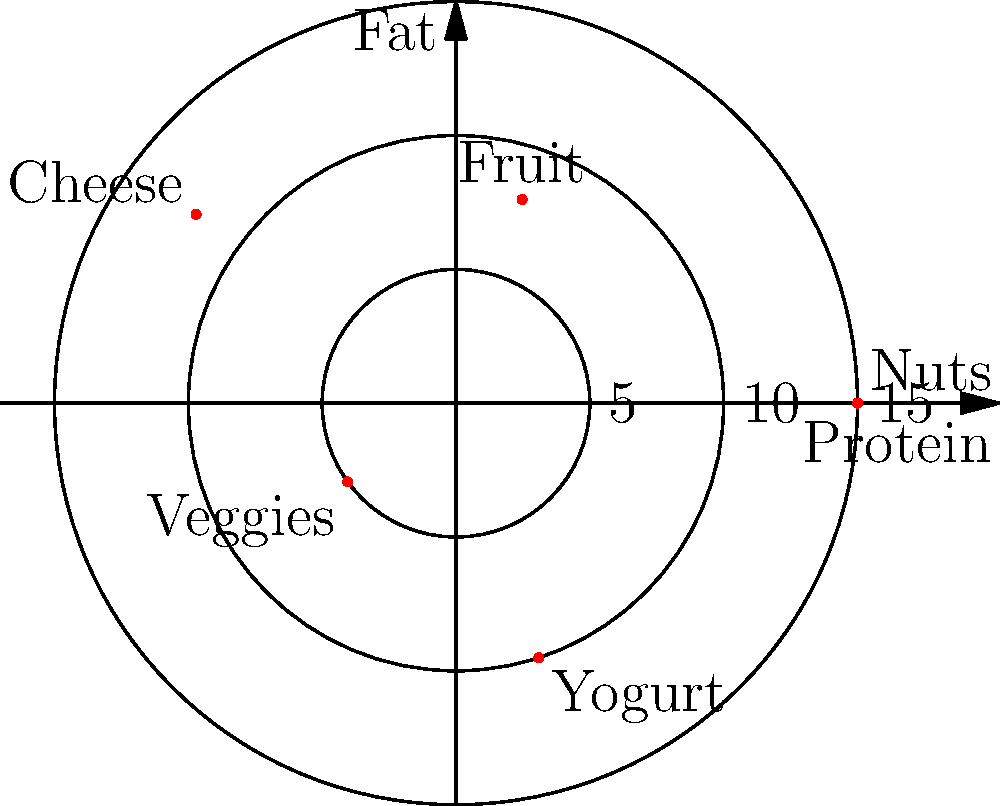The polar graph above represents the nutritional content of five popular child snacks. Each snack is plotted based on its protein content (x-axis) and fat content (y-axis) in grams per serving. Which snack has the highest protein content? To determine which snack has the highest protein content, we need to analyze the x-axis values for each plotted point:

1. First, identify each snack on the graph:
   - Nuts: located at 0 degrees
   - Fruit: located at 72 degrees
   - Cheese: located at 144 degrees
   - Veggies: located at 216 degrees
   - Yogurt: located at 288 degrees

2. The protein content is represented by the x-axis (horizontal axis).

3. Compare the x-axis values for each snack:
   - Nuts: Furthest right on the x-axis, about 15 grams
   - Fruit: Close to the origin, about 8 grams
   - Cheese: Negative x-value, about -12 grams
   - Veggies: Negative x-value, close to origin, about -5 grams
   - Yogurt: Positive x-value, about 10 grams

4. The snack with the highest positive x-value has the highest protein content.

5. Nuts have the highest x-value at approximately 15 grams of protein per serving.

Therefore, nuts have the highest protein content among the given snacks.
Answer: Nuts 